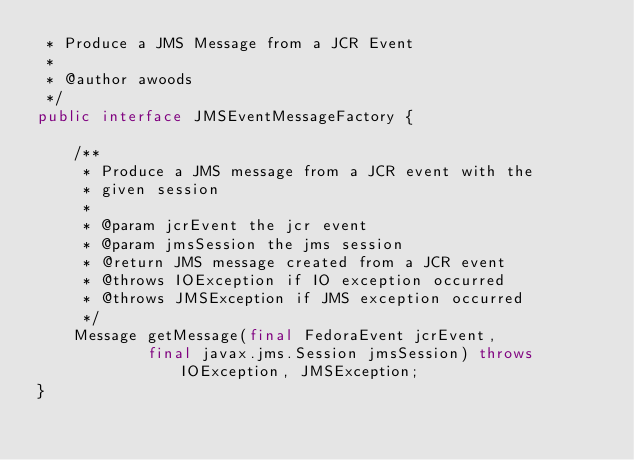Convert code to text. <code><loc_0><loc_0><loc_500><loc_500><_Java_> * Produce a JMS Message from a JCR Event
 *
 * @author awoods
 */
public interface JMSEventMessageFactory {

    /**
     * Produce a JMS message from a JCR event with the
     * given session
     *
     * @param jcrEvent the jcr event
     * @param jmsSession the jms session
     * @return JMS message created from a JCR event
     * @throws IOException if IO exception occurred
     * @throws JMSException if JMS exception occurred
     */
    Message getMessage(final FedoraEvent jcrEvent,
            final javax.jms.Session jmsSession) throws IOException, JMSException;
}
</code> 